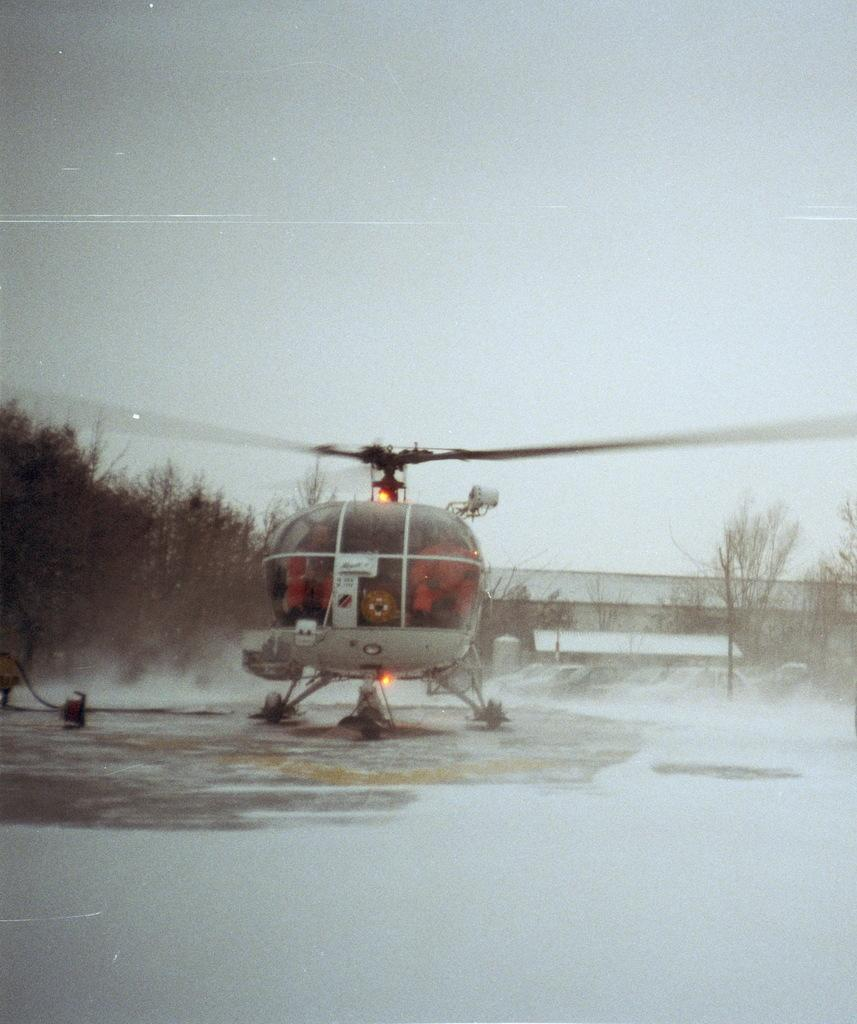What is the main subject of the image? The main subject of the image is a helicopter. Where is the helicopter located in the image? The helicopter is on the ground in the image. What can be seen in the background of the image? There are trees, vehicles, and the sky visible in the background of the image. What type of sugar is being used to fuel the helicopter in the image? There is no sugar present in the image, and helicopters do not use sugar as fuel. 